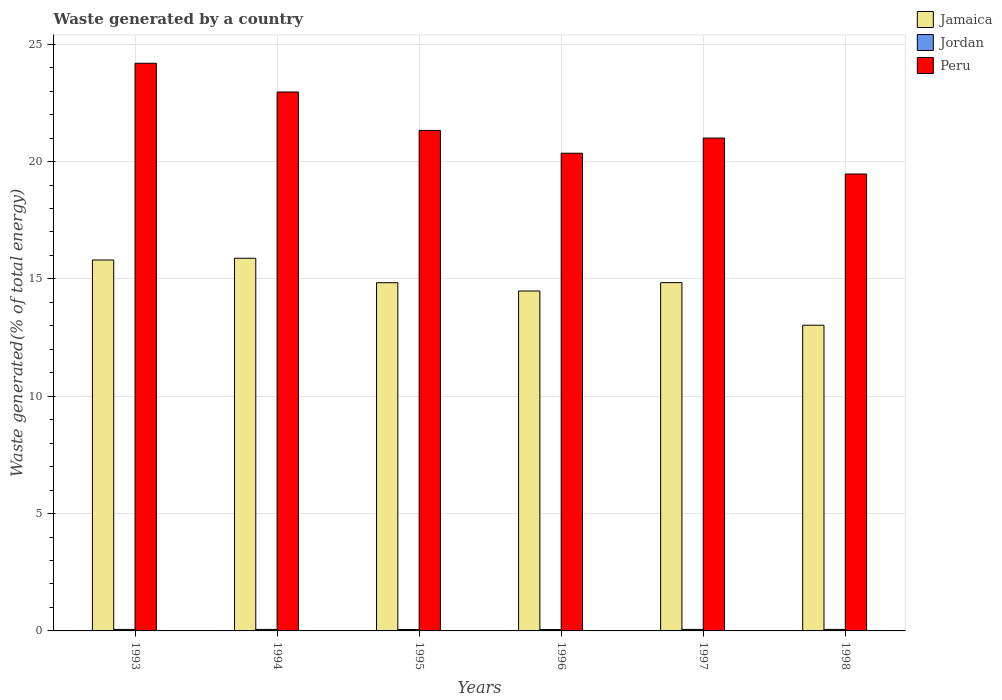How many different coloured bars are there?
Your response must be concise. 3. How many bars are there on the 1st tick from the left?
Offer a terse response. 3. What is the total waste generated in Peru in 1996?
Provide a succinct answer. 20.36. Across all years, what is the maximum total waste generated in Jordan?
Your response must be concise. 0.06. Across all years, what is the minimum total waste generated in Jamaica?
Provide a succinct answer. 13.03. What is the total total waste generated in Peru in the graph?
Give a very brief answer. 129.31. What is the difference between the total waste generated in Peru in 1996 and that in 1998?
Keep it short and to the point. 0.89. What is the difference between the total waste generated in Peru in 1997 and the total waste generated in Jordan in 1996?
Your response must be concise. 20.94. What is the average total waste generated in Jordan per year?
Provide a short and direct response. 0.06. In the year 1994, what is the difference between the total waste generated in Jamaica and total waste generated in Peru?
Offer a very short reply. -7.08. In how many years, is the total waste generated in Peru greater than 21 %?
Offer a terse response. 4. What is the ratio of the total waste generated in Peru in 1993 to that in 1998?
Your answer should be compact. 1.24. What is the difference between the highest and the second highest total waste generated in Jordan?
Your response must be concise. 0. What is the difference between the highest and the lowest total waste generated in Jordan?
Your answer should be very brief. 0.01. In how many years, is the total waste generated in Peru greater than the average total waste generated in Peru taken over all years?
Provide a short and direct response. 2. Is the sum of the total waste generated in Peru in 1993 and 1998 greater than the maximum total waste generated in Jordan across all years?
Your answer should be compact. Yes. What does the 3rd bar from the left in 1996 represents?
Make the answer very short. Peru. What does the 2nd bar from the right in 1993 represents?
Provide a succinct answer. Jordan. How many years are there in the graph?
Your answer should be compact. 6. Does the graph contain grids?
Offer a terse response. Yes. Where does the legend appear in the graph?
Make the answer very short. Top right. How many legend labels are there?
Make the answer very short. 3. What is the title of the graph?
Keep it short and to the point. Waste generated by a country. Does "Central Europe" appear as one of the legend labels in the graph?
Ensure brevity in your answer.  No. What is the label or title of the Y-axis?
Offer a very short reply. Waste generated(% of total energy). What is the Waste generated(% of total energy) in Jamaica in 1993?
Provide a short and direct response. 15.81. What is the Waste generated(% of total energy) of Jordan in 1993?
Give a very brief answer. 0.06. What is the Waste generated(% of total energy) in Peru in 1993?
Your answer should be very brief. 24.19. What is the Waste generated(% of total energy) in Jamaica in 1994?
Ensure brevity in your answer.  15.88. What is the Waste generated(% of total energy) of Jordan in 1994?
Keep it short and to the point. 0.06. What is the Waste generated(% of total energy) in Peru in 1994?
Offer a terse response. 22.97. What is the Waste generated(% of total energy) of Jamaica in 1995?
Make the answer very short. 14.84. What is the Waste generated(% of total energy) in Jordan in 1995?
Keep it short and to the point. 0.06. What is the Waste generated(% of total energy) in Peru in 1995?
Offer a terse response. 21.33. What is the Waste generated(% of total energy) in Jamaica in 1996?
Make the answer very short. 14.48. What is the Waste generated(% of total energy) of Jordan in 1996?
Provide a succinct answer. 0.06. What is the Waste generated(% of total energy) in Peru in 1996?
Your response must be concise. 20.36. What is the Waste generated(% of total energy) in Jamaica in 1997?
Ensure brevity in your answer.  14.84. What is the Waste generated(% of total energy) of Jordan in 1997?
Ensure brevity in your answer.  0.06. What is the Waste generated(% of total energy) of Peru in 1997?
Make the answer very short. 21. What is the Waste generated(% of total energy) in Jamaica in 1998?
Offer a terse response. 13.03. What is the Waste generated(% of total energy) of Jordan in 1998?
Your response must be concise. 0.06. What is the Waste generated(% of total energy) of Peru in 1998?
Your answer should be very brief. 19.47. Across all years, what is the maximum Waste generated(% of total energy) in Jamaica?
Offer a very short reply. 15.88. Across all years, what is the maximum Waste generated(% of total energy) of Jordan?
Your answer should be compact. 0.06. Across all years, what is the maximum Waste generated(% of total energy) of Peru?
Keep it short and to the point. 24.19. Across all years, what is the minimum Waste generated(% of total energy) of Jamaica?
Offer a very short reply. 13.03. Across all years, what is the minimum Waste generated(% of total energy) in Jordan?
Keep it short and to the point. 0.06. Across all years, what is the minimum Waste generated(% of total energy) of Peru?
Provide a short and direct response. 19.47. What is the total Waste generated(% of total energy) of Jamaica in the graph?
Your answer should be compact. 88.88. What is the total Waste generated(% of total energy) of Jordan in the graph?
Your answer should be very brief. 0.37. What is the total Waste generated(% of total energy) in Peru in the graph?
Keep it short and to the point. 129.31. What is the difference between the Waste generated(% of total energy) of Jamaica in 1993 and that in 1994?
Offer a very short reply. -0.07. What is the difference between the Waste generated(% of total energy) of Jordan in 1993 and that in 1994?
Make the answer very short. -0. What is the difference between the Waste generated(% of total energy) of Peru in 1993 and that in 1994?
Keep it short and to the point. 1.22. What is the difference between the Waste generated(% of total energy) in Jordan in 1993 and that in 1995?
Provide a short and direct response. 0. What is the difference between the Waste generated(% of total energy) of Peru in 1993 and that in 1995?
Make the answer very short. 2.86. What is the difference between the Waste generated(% of total energy) in Jamaica in 1993 and that in 1996?
Your answer should be compact. 1.32. What is the difference between the Waste generated(% of total energy) in Jordan in 1993 and that in 1996?
Give a very brief answer. 0. What is the difference between the Waste generated(% of total energy) of Peru in 1993 and that in 1996?
Your answer should be compact. 3.83. What is the difference between the Waste generated(% of total energy) in Jamaica in 1993 and that in 1997?
Offer a very short reply. 0.96. What is the difference between the Waste generated(% of total energy) in Jordan in 1993 and that in 1997?
Give a very brief answer. -0. What is the difference between the Waste generated(% of total energy) of Peru in 1993 and that in 1997?
Give a very brief answer. 3.19. What is the difference between the Waste generated(% of total energy) of Jamaica in 1993 and that in 1998?
Offer a very short reply. 2.78. What is the difference between the Waste generated(% of total energy) in Jordan in 1993 and that in 1998?
Provide a short and direct response. -0. What is the difference between the Waste generated(% of total energy) of Peru in 1993 and that in 1998?
Offer a terse response. 4.72. What is the difference between the Waste generated(% of total energy) in Jamaica in 1994 and that in 1995?
Offer a very short reply. 1.04. What is the difference between the Waste generated(% of total energy) of Jordan in 1994 and that in 1995?
Your answer should be very brief. 0. What is the difference between the Waste generated(% of total energy) of Peru in 1994 and that in 1995?
Provide a succinct answer. 1.64. What is the difference between the Waste generated(% of total energy) of Jamaica in 1994 and that in 1996?
Make the answer very short. 1.4. What is the difference between the Waste generated(% of total energy) of Jordan in 1994 and that in 1996?
Provide a short and direct response. 0.01. What is the difference between the Waste generated(% of total energy) of Peru in 1994 and that in 1996?
Your answer should be very brief. 2.61. What is the difference between the Waste generated(% of total energy) in Jordan in 1994 and that in 1997?
Your answer should be very brief. -0. What is the difference between the Waste generated(% of total energy) in Peru in 1994 and that in 1997?
Offer a terse response. 1.96. What is the difference between the Waste generated(% of total energy) in Jamaica in 1994 and that in 1998?
Give a very brief answer. 2.85. What is the difference between the Waste generated(% of total energy) of Jordan in 1994 and that in 1998?
Make the answer very short. 0. What is the difference between the Waste generated(% of total energy) of Peru in 1994 and that in 1998?
Your response must be concise. 3.49. What is the difference between the Waste generated(% of total energy) of Jamaica in 1995 and that in 1996?
Your answer should be compact. 0.35. What is the difference between the Waste generated(% of total energy) of Jordan in 1995 and that in 1996?
Provide a succinct answer. 0. What is the difference between the Waste generated(% of total energy) of Peru in 1995 and that in 1996?
Provide a succinct answer. 0.97. What is the difference between the Waste generated(% of total energy) in Jamaica in 1995 and that in 1997?
Offer a very short reply. -0. What is the difference between the Waste generated(% of total energy) of Jordan in 1995 and that in 1997?
Your response must be concise. -0. What is the difference between the Waste generated(% of total energy) of Peru in 1995 and that in 1997?
Ensure brevity in your answer.  0.33. What is the difference between the Waste generated(% of total energy) in Jamaica in 1995 and that in 1998?
Give a very brief answer. 1.81. What is the difference between the Waste generated(% of total energy) in Jordan in 1995 and that in 1998?
Offer a very short reply. -0. What is the difference between the Waste generated(% of total energy) of Peru in 1995 and that in 1998?
Your answer should be compact. 1.86. What is the difference between the Waste generated(% of total energy) of Jamaica in 1996 and that in 1997?
Offer a very short reply. -0.36. What is the difference between the Waste generated(% of total energy) of Jordan in 1996 and that in 1997?
Offer a very short reply. -0.01. What is the difference between the Waste generated(% of total energy) of Peru in 1996 and that in 1997?
Your answer should be very brief. -0.65. What is the difference between the Waste generated(% of total energy) of Jamaica in 1996 and that in 1998?
Your response must be concise. 1.46. What is the difference between the Waste generated(% of total energy) in Jordan in 1996 and that in 1998?
Make the answer very short. -0.01. What is the difference between the Waste generated(% of total energy) in Peru in 1996 and that in 1998?
Make the answer very short. 0.89. What is the difference between the Waste generated(% of total energy) in Jamaica in 1997 and that in 1998?
Keep it short and to the point. 1.81. What is the difference between the Waste generated(% of total energy) of Jordan in 1997 and that in 1998?
Your answer should be compact. 0. What is the difference between the Waste generated(% of total energy) in Peru in 1997 and that in 1998?
Ensure brevity in your answer.  1.53. What is the difference between the Waste generated(% of total energy) in Jamaica in 1993 and the Waste generated(% of total energy) in Jordan in 1994?
Provide a short and direct response. 15.74. What is the difference between the Waste generated(% of total energy) of Jamaica in 1993 and the Waste generated(% of total energy) of Peru in 1994?
Provide a short and direct response. -7.16. What is the difference between the Waste generated(% of total energy) of Jordan in 1993 and the Waste generated(% of total energy) of Peru in 1994?
Offer a terse response. -22.9. What is the difference between the Waste generated(% of total energy) of Jamaica in 1993 and the Waste generated(% of total energy) of Jordan in 1995?
Make the answer very short. 15.75. What is the difference between the Waste generated(% of total energy) of Jamaica in 1993 and the Waste generated(% of total energy) of Peru in 1995?
Keep it short and to the point. -5.52. What is the difference between the Waste generated(% of total energy) of Jordan in 1993 and the Waste generated(% of total energy) of Peru in 1995?
Your response must be concise. -21.26. What is the difference between the Waste generated(% of total energy) in Jamaica in 1993 and the Waste generated(% of total energy) in Jordan in 1996?
Offer a very short reply. 15.75. What is the difference between the Waste generated(% of total energy) in Jamaica in 1993 and the Waste generated(% of total energy) in Peru in 1996?
Make the answer very short. -4.55. What is the difference between the Waste generated(% of total energy) of Jordan in 1993 and the Waste generated(% of total energy) of Peru in 1996?
Provide a short and direct response. -20.29. What is the difference between the Waste generated(% of total energy) of Jamaica in 1993 and the Waste generated(% of total energy) of Jordan in 1997?
Provide a short and direct response. 15.74. What is the difference between the Waste generated(% of total energy) in Jamaica in 1993 and the Waste generated(% of total energy) in Peru in 1997?
Your answer should be compact. -5.19. What is the difference between the Waste generated(% of total energy) in Jordan in 1993 and the Waste generated(% of total energy) in Peru in 1997?
Give a very brief answer. -20.94. What is the difference between the Waste generated(% of total energy) of Jamaica in 1993 and the Waste generated(% of total energy) of Jordan in 1998?
Make the answer very short. 15.74. What is the difference between the Waste generated(% of total energy) of Jamaica in 1993 and the Waste generated(% of total energy) of Peru in 1998?
Ensure brevity in your answer.  -3.66. What is the difference between the Waste generated(% of total energy) of Jordan in 1993 and the Waste generated(% of total energy) of Peru in 1998?
Ensure brevity in your answer.  -19.41. What is the difference between the Waste generated(% of total energy) in Jamaica in 1994 and the Waste generated(% of total energy) in Jordan in 1995?
Ensure brevity in your answer.  15.82. What is the difference between the Waste generated(% of total energy) in Jamaica in 1994 and the Waste generated(% of total energy) in Peru in 1995?
Keep it short and to the point. -5.45. What is the difference between the Waste generated(% of total energy) in Jordan in 1994 and the Waste generated(% of total energy) in Peru in 1995?
Keep it short and to the point. -21.26. What is the difference between the Waste generated(% of total energy) in Jamaica in 1994 and the Waste generated(% of total energy) in Jordan in 1996?
Ensure brevity in your answer.  15.82. What is the difference between the Waste generated(% of total energy) of Jamaica in 1994 and the Waste generated(% of total energy) of Peru in 1996?
Offer a terse response. -4.48. What is the difference between the Waste generated(% of total energy) in Jordan in 1994 and the Waste generated(% of total energy) in Peru in 1996?
Offer a terse response. -20.29. What is the difference between the Waste generated(% of total energy) in Jamaica in 1994 and the Waste generated(% of total energy) in Jordan in 1997?
Your answer should be compact. 15.82. What is the difference between the Waste generated(% of total energy) in Jamaica in 1994 and the Waste generated(% of total energy) in Peru in 1997?
Provide a short and direct response. -5.12. What is the difference between the Waste generated(% of total energy) of Jordan in 1994 and the Waste generated(% of total energy) of Peru in 1997?
Your answer should be very brief. -20.94. What is the difference between the Waste generated(% of total energy) of Jamaica in 1994 and the Waste generated(% of total energy) of Jordan in 1998?
Your answer should be compact. 15.82. What is the difference between the Waste generated(% of total energy) in Jamaica in 1994 and the Waste generated(% of total energy) in Peru in 1998?
Offer a terse response. -3.59. What is the difference between the Waste generated(% of total energy) of Jordan in 1994 and the Waste generated(% of total energy) of Peru in 1998?
Your response must be concise. -19.41. What is the difference between the Waste generated(% of total energy) in Jamaica in 1995 and the Waste generated(% of total energy) in Jordan in 1996?
Make the answer very short. 14.78. What is the difference between the Waste generated(% of total energy) of Jamaica in 1995 and the Waste generated(% of total energy) of Peru in 1996?
Keep it short and to the point. -5.52. What is the difference between the Waste generated(% of total energy) in Jordan in 1995 and the Waste generated(% of total energy) in Peru in 1996?
Make the answer very short. -20.3. What is the difference between the Waste generated(% of total energy) of Jamaica in 1995 and the Waste generated(% of total energy) of Jordan in 1997?
Your response must be concise. 14.77. What is the difference between the Waste generated(% of total energy) of Jamaica in 1995 and the Waste generated(% of total energy) of Peru in 1997?
Your answer should be very brief. -6.16. What is the difference between the Waste generated(% of total energy) of Jordan in 1995 and the Waste generated(% of total energy) of Peru in 1997?
Keep it short and to the point. -20.94. What is the difference between the Waste generated(% of total energy) in Jamaica in 1995 and the Waste generated(% of total energy) in Jordan in 1998?
Provide a succinct answer. 14.78. What is the difference between the Waste generated(% of total energy) in Jamaica in 1995 and the Waste generated(% of total energy) in Peru in 1998?
Offer a very short reply. -4.63. What is the difference between the Waste generated(% of total energy) in Jordan in 1995 and the Waste generated(% of total energy) in Peru in 1998?
Give a very brief answer. -19.41. What is the difference between the Waste generated(% of total energy) of Jamaica in 1996 and the Waste generated(% of total energy) of Jordan in 1997?
Offer a very short reply. 14.42. What is the difference between the Waste generated(% of total energy) in Jamaica in 1996 and the Waste generated(% of total energy) in Peru in 1997?
Make the answer very short. -6.52. What is the difference between the Waste generated(% of total energy) in Jordan in 1996 and the Waste generated(% of total energy) in Peru in 1997?
Your answer should be compact. -20.94. What is the difference between the Waste generated(% of total energy) in Jamaica in 1996 and the Waste generated(% of total energy) in Jordan in 1998?
Ensure brevity in your answer.  14.42. What is the difference between the Waste generated(% of total energy) in Jamaica in 1996 and the Waste generated(% of total energy) in Peru in 1998?
Make the answer very short. -4.99. What is the difference between the Waste generated(% of total energy) in Jordan in 1996 and the Waste generated(% of total energy) in Peru in 1998?
Your answer should be compact. -19.41. What is the difference between the Waste generated(% of total energy) of Jamaica in 1997 and the Waste generated(% of total energy) of Jordan in 1998?
Ensure brevity in your answer.  14.78. What is the difference between the Waste generated(% of total energy) of Jamaica in 1997 and the Waste generated(% of total energy) of Peru in 1998?
Your response must be concise. -4.63. What is the difference between the Waste generated(% of total energy) of Jordan in 1997 and the Waste generated(% of total energy) of Peru in 1998?
Offer a very short reply. -19.41. What is the average Waste generated(% of total energy) in Jamaica per year?
Your answer should be compact. 14.81. What is the average Waste generated(% of total energy) of Jordan per year?
Provide a short and direct response. 0.06. What is the average Waste generated(% of total energy) in Peru per year?
Make the answer very short. 21.55. In the year 1993, what is the difference between the Waste generated(% of total energy) in Jamaica and Waste generated(% of total energy) in Jordan?
Give a very brief answer. 15.74. In the year 1993, what is the difference between the Waste generated(% of total energy) in Jamaica and Waste generated(% of total energy) in Peru?
Your response must be concise. -8.38. In the year 1993, what is the difference between the Waste generated(% of total energy) of Jordan and Waste generated(% of total energy) of Peru?
Give a very brief answer. -24.13. In the year 1994, what is the difference between the Waste generated(% of total energy) of Jamaica and Waste generated(% of total energy) of Jordan?
Your answer should be compact. 15.82. In the year 1994, what is the difference between the Waste generated(% of total energy) in Jamaica and Waste generated(% of total energy) in Peru?
Ensure brevity in your answer.  -7.08. In the year 1994, what is the difference between the Waste generated(% of total energy) in Jordan and Waste generated(% of total energy) in Peru?
Your answer should be very brief. -22.9. In the year 1995, what is the difference between the Waste generated(% of total energy) of Jamaica and Waste generated(% of total energy) of Jordan?
Your answer should be very brief. 14.78. In the year 1995, what is the difference between the Waste generated(% of total energy) of Jamaica and Waste generated(% of total energy) of Peru?
Offer a very short reply. -6.49. In the year 1995, what is the difference between the Waste generated(% of total energy) of Jordan and Waste generated(% of total energy) of Peru?
Make the answer very short. -21.27. In the year 1996, what is the difference between the Waste generated(% of total energy) of Jamaica and Waste generated(% of total energy) of Jordan?
Give a very brief answer. 14.43. In the year 1996, what is the difference between the Waste generated(% of total energy) in Jamaica and Waste generated(% of total energy) in Peru?
Make the answer very short. -5.87. In the year 1996, what is the difference between the Waste generated(% of total energy) of Jordan and Waste generated(% of total energy) of Peru?
Your answer should be very brief. -20.3. In the year 1997, what is the difference between the Waste generated(% of total energy) in Jamaica and Waste generated(% of total energy) in Jordan?
Provide a short and direct response. 14.78. In the year 1997, what is the difference between the Waste generated(% of total energy) of Jamaica and Waste generated(% of total energy) of Peru?
Ensure brevity in your answer.  -6.16. In the year 1997, what is the difference between the Waste generated(% of total energy) of Jordan and Waste generated(% of total energy) of Peru?
Provide a succinct answer. -20.94. In the year 1998, what is the difference between the Waste generated(% of total energy) in Jamaica and Waste generated(% of total energy) in Jordan?
Your answer should be very brief. 12.96. In the year 1998, what is the difference between the Waste generated(% of total energy) in Jamaica and Waste generated(% of total energy) in Peru?
Offer a terse response. -6.44. In the year 1998, what is the difference between the Waste generated(% of total energy) of Jordan and Waste generated(% of total energy) of Peru?
Your response must be concise. -19.41. What is the ratio of the Waste generated(% of total energy) of Jamaica in 1993 to that in 1994?
Make the answer very short. 1. What is the ratio of the Waste generated(% of total energy) in Jordan in 1993 to that in 1994?
Make the answer very short. 0.97. What is the ratio of the Waste generated(% of total energy) of Peru in 1993 to that in 1994?
Your answer should be compact. 1.05. What is the ratio of the Waste generated(% of total energy) of Jamaica in 1993 to that in 1995?
Make the answer very short. 1.07. What is the ratio of the Waste generated(% of total energy) in Jordan in 1993 to that in 1995?
Offer a very short reply. 1.04. What is the ratio of the Waste generated(% of total energy) of Peru in 1993 to that in 1995?
Ensure brevity in your answer.  1.13. What is the ratio of the Waste generated(% of total energy) in Jamaica in 1993 to that in 1996?
Give a very brief answer. 1.09. What is the ratio of the Waste generated(% of total energy) of Jordan in 1993 to that in 1996?
Offer a terse response. 1.06. What is the ratio of the Waste generated(% of total energy) of Peru in 1993 to that in 1996?
Your answer should be very brief. 1.19. What is the ratio of the Waste generated(% of total energy) of Jamaica in 1993 to that in 1997?
Keep it short and to the point. 1.06. What is the ratio of the Waste generated(% of total energy) of Jordan in 1993 to that in 1997?
Provide a succinct answer. 0.97. What is the ratio of the Waste generated(% of total energy) in Peru in 1993 to that in 1997?
Your answer should be very brief. 1.15. What is the ratio of the Waste generated(% of total energy) of Jamaica in 1993 to that in 1998?
Offer a terse response. 1.21. What is the ratio of the Waste generated(% of total energy) in Jordan in 1993 to that in 1998?
Ensure brevity in your answer.  0.98. What is the ratio of the Waste generated(% of total energy) of Peru in 1993 to that in 1998?
Your response must be concise. 1.24. What is the ratio of the Waste generated(% of total energy) in Jamaica in 1994 to that in 1995?
Keep it short and to the point. 1.07. What is the ratio of the Waste generated(% of total energy) of Jordan in 1994 to that in 1995?
Provide a succinct answer. 1.07. What is the ratio of the Waste generated(% of total energy) in Peru in 1994 to that in 1995?
Offer a terse response. 1.08. What is the ratio of the Waste generated(% of total energy) of Jamaica in 1994 to that in 1996?
Provide a succinct answer. 1.1. What is the ratio of the Waste generated(% of total energy) of Jordan in 1994 to that in 1996?
Give a very brief answer. 1.09. What is the ratio of the Waste generated(% of total energy) in Peru in 1994 to that in 1996?
Provide a succinct answer. 1.13. What is the ratio of the Waste generated(% of total energy) of Jamaica in 1994 to that in 1997?
Keep it short and to the point. 1.07. What is the ratio of the Waste generated(% of total energy) in Jordan in 1994 to that in 1997?
Make the answer very short. 1. What is the ratio of the Waste generated(% of total energy) in Peru in 1994 to that in 1997?
Ensure brevity in your answer.  1.09. What is the ratio of the Waste generated(% of total energy) of Jamaica in 1994 to that in 1998?
Your response must be concise. 1.22. What is the ratio of the Waste generated(% of total energy) of Jordan in 1994 to that in 1998?
Keep it short and to the point. 1.01. What is the ratio of the Waste generated(% of total energy) of Peru in 1994 to that in 1998?
Your answer should be compact. 1.18. What is the ratio of the Waste generated(% of total energy) of Jamaica in 1995 to that in 1996?
Offer a very short reply. 1.02. What is the ratio of the Waste generated(% of total energy) in Jordan in 1995 to that in 1996?
Your answer should be very brief. 1.03. What is the ratio of the Waste generated(% of total energy) of Peru in 1995 to that in 1996?
Your answer should be compact. 1.05. What is the ratio of the Waste generated(% of total energy) of Jamaica in 1995 to that in 1997?
Ensure brevity in your answer.  1. What is the ratio of the Waste generated(% of total energy) of Jordan in 1995 to that in 1997?
Your answer should be very brief. 0.94. What is the ratio of the Waste generated(% of total energy) in Peru in 1995 to that in 1997?
Ensure brevity in your answer.  1.02. What is the ratio of the Waste generated(% of total energy) of Jamaica in 1995 to that in 1998?
Give a very brief answer. 1.14. What is the ratio of the Waste generated(% of total energy) in Jordan in 1995 to that in 1998?
Your answer should be very brief. 0.95. What is the ratio of the Waste generated(% of total energy) in Peru in 1995 to that in 1998?
Provide a succinct answer. 1.1. What is the ratio of the Waste generated(% of total energy) of Jamaica in 1996 to that in 1997?
Offer a terse response. 0.98. What is the ratio of the Waste generated(% of total energy) in Jordan in 1996 to that in 1997?
Your response must be concise. 0.91. What is the ratio of the Waste generated(% of total energy) in Peru in 1996 to that in 1997?
Your response must be concise. 0.97. What is the ratio of the Waste generated(% of total energy) of Jamaica in 1996 to that in 1998?
Keep it short and to the point. 1.11. What is the ratio of the Waste generated(% of total energy) in Jordan in 1996 to that in 1998?
Keep it short and to the point. 0.92. What is the ratio of the Waste generated(% of total energy) of Peru in 1996 to that in 1998?
Your response must be concise. 1.05. What is the ratio of the Waste generated(% of total energy) in Jamaica in 1997 to that in 1998?
Offer a terse response. 1.14. What is the ratio of the Waste generated(% of total energy) of Jordan in 1997 to that in 1998?
Give a very brief answer. 1.01. What is the ratio of the Waste generated(% of total energy) in Peru in 1997 to that in 1998?
Your answer should be very brief. 1.08. What is the difference between the highest and the second highest Waste generated(% of total energy) of Jamaica?
Your answer should be compact. 0.07. What is the difference between the highest and the second highest Waste generated(% of total energy) in Peru?
Your answer should be very brief. 1.22. What is the difference between the highest and the lowest Waste generated(% of total energy) of Jamaica?
Provide a short and direct response. 2.85. What is the difference between the highest and the lowest Waste generated(% of total energy) of Jordan?
Your response must be concise. 0.01. What is the difference between the highest and the lowest Waste generated(% of total energy) in Peru?
Provide a short and direct response. 4.72. 